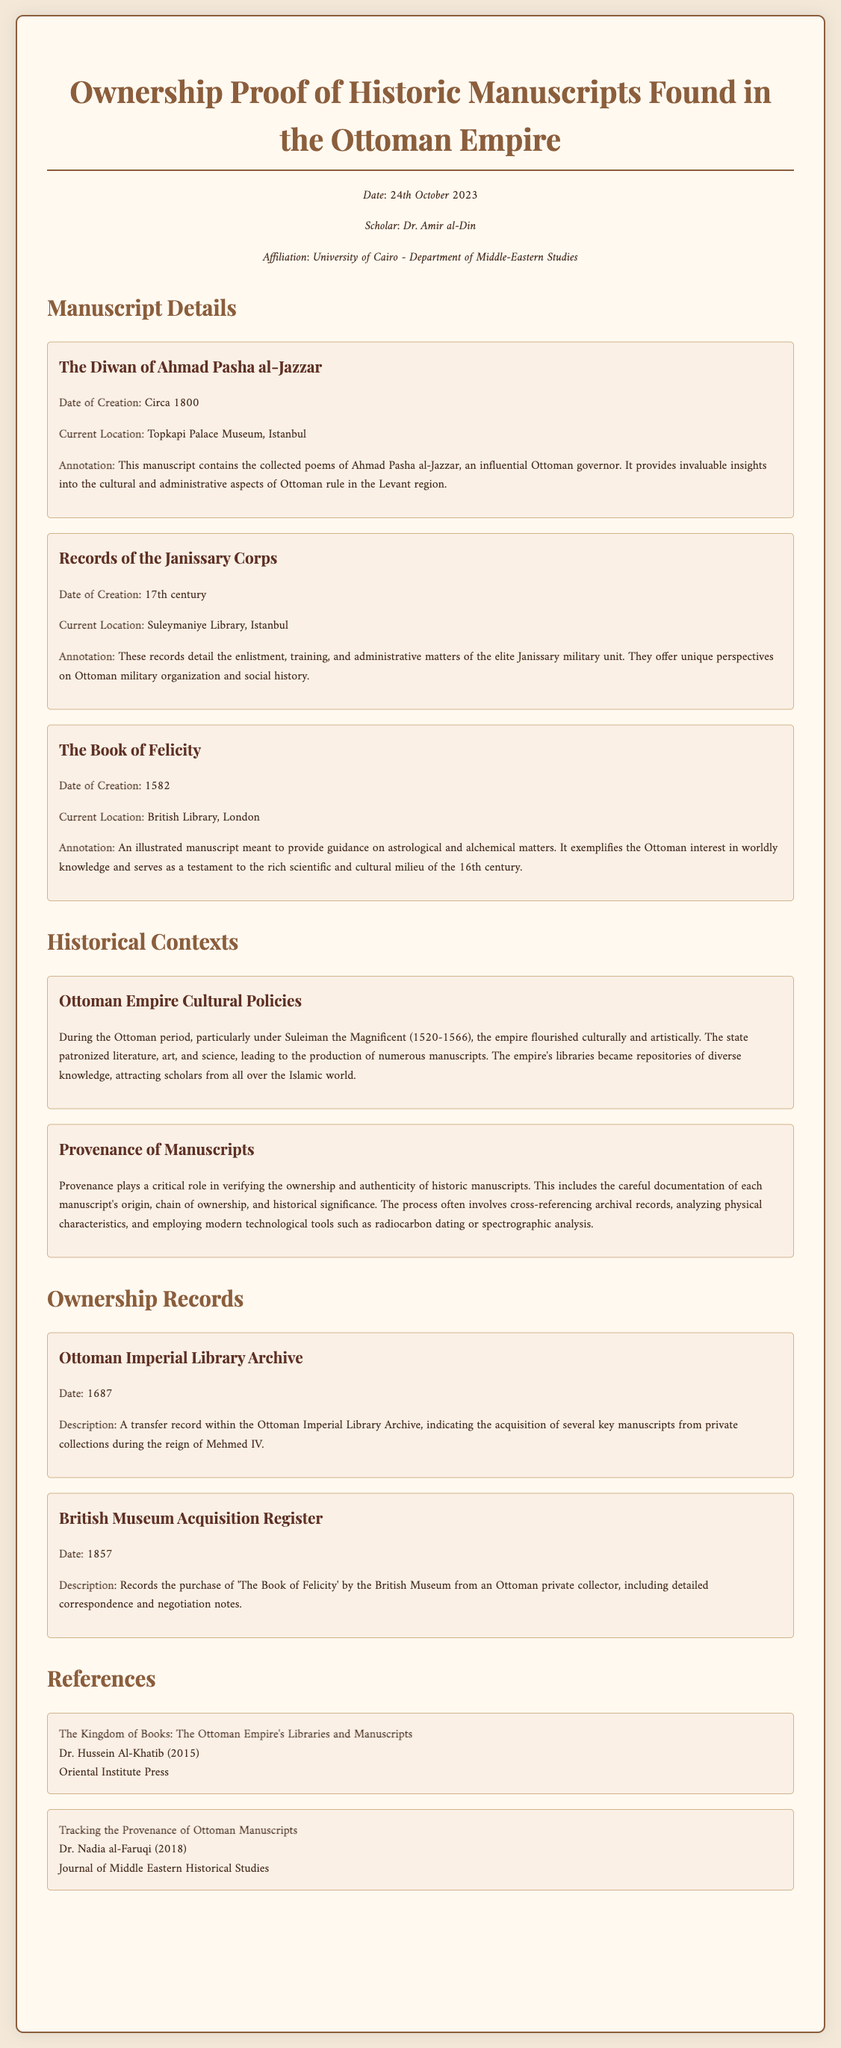what is the title of the first manuscript? The title of the first manuscript is stated clearly in the document under the manuscript details section.
Answer: The Diwan of Ahmad Pasha al-Jazzar who created 'The Book of Felicity'? The document describes 'The Book of Felicity' and provides the date of creation under the manuscript details section.
Answer: 1582 where is the current location of the Records of the Janissary Corps? The current location is mentioned in the details of the manuscript in the document.
Answer: Suleymaniye Library, Istanbul what year was the Ottoman Imperial Library Archive record dated? The year of the Ottoman Imperial Library Archive record is explicitly stated in the ownership records section.
Answer: 1687 what significant cultural policies are discussed in the historical contexts? The section on historical contexts mentions specific themes related to the Ottoman Empire's cultural approach during a notable period.
Answer: Ottoman Empire Cultural Policies how does the document describe the importance of provenance? The document provides a detailed explanation about provenance within the historical contexts section, discussing its significance in the assessment of manuscripts.
Answer: Verifying ownership and authenticity who authored the reference titled 'Tracking the Provenance of Ottoman Manuscripts'? The authorship of the reference is presented in a list format under the references section in the document.
Answer: Dr. Nadia al-Faruqi when was 'The Book of Felicity' purchased by the British Museum? The purchase date is summarized clearly in the document within the ownership records.
Answer: 1857 what is the affiliation of the scholar who drafted this document? The document specifies the scholar's affiliation in the metadata section.
Answer: University of Cairo - Department of Middle-Eastern Studies 